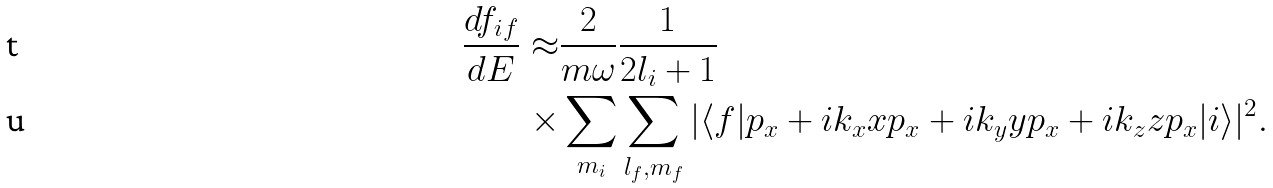<formula> <loc_0><loc_0><loc_500><loc_500>\frac { d f _ { i f } } { d E } \approx & \frac { 2 } { m \omega } \frac { 1 } { 2 l _ { i } + 1 } \\ \times & \sum _ { m _ { i } } \sum _ { l _ { f } , m _ { f } } | \langle f | p _ { x } + i k _ { x } x p _ { x } + i k _ { y } y p _ { x } + i k _ { z } z p _ { x } | i \rangle | ^ { 2 } .</formula> 